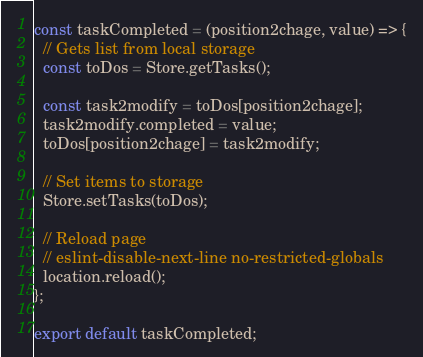Convert code to text. <code><loc_0><loc_0><loc_500><loc_500><_JavaScript_>
const taskCompleted = (position2chage, value) => {
  // Gets list from local storage
  const toDos = Store.getTasks();

  const task2modify = toDos[position2chage];
  task2modify.completed = value;
  toDos[position2chage] = task2modify;

  // Set items to storage
  Store.setTasks(toDos);

  // Reload page
  // eslint-disable-next-line no-restricted-globals
  location.reload();
};

export default taskCompleted;</code> 